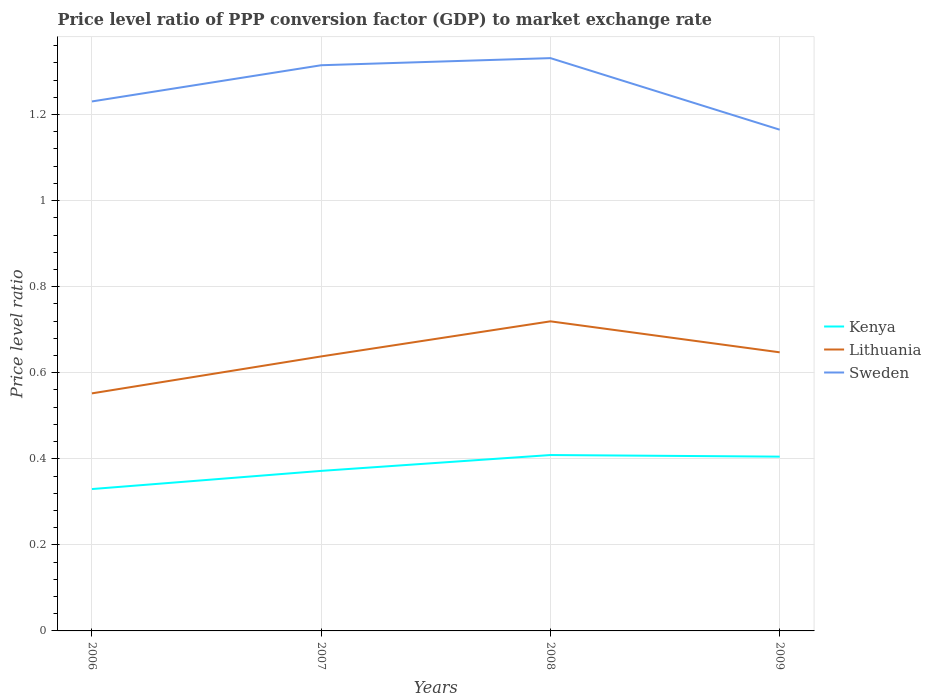How many different coloured lines are there?
Offer a very short reply. 3. Is the number of lines equal to the number of legend labels?
Make the answer very short. Yes. Across all years, what is the maximum price level ratio in Kenya?
Provide a succinct answer. 0.33. What is the total price level ratio in Sweden in the graph?
Your response must be concise. 0.07. What is the difference between the highest and the second highest price level ratio in Kenya?
Your answer should be compact. 0.08. What is the difference between the highest and the lowest price level ratio in Lithuania?
Make the answer very short. 2. Is the price level ratio in Kenya strictly greater than the price level ratio in Lithuania over the years?
Ensure brevity in your answer.  Yes. How many lines are there?
Provide a succinct answer. 3. How many years are there in the graph?
Your response must be concise. 4. What is the difference between two consecutive major ticks on the Y-axis?
Keep it short and to the point. 0.2. Does the graph contain any zero values?
Provide a succinct answer. No. Does the graph contain grids?
Your answer should be compact. Yes. Where does the legend appear in the graph?
Provide a succinct answer. Center right. How are the legend labels stacked?
Your answer should be compact. Vertical. What is the title of the graph?
Offer a very short reply. Price level ratio of PPP conversion factor (GDP) to market exchange rate. What is the label or title of the X-axis?
Your answer should be compact. Years. What is the label or title of the Y-axis?
Your response must be concise. Price level ratio. What is the Price level ratio in Kenya in 2006?
Give a very brief answer. 0.33. What is the Price level ratio of Lithuania in 2006?
Ensure brevity in your answer.  0.55. What is the Price level ratio of Sweden in 2006?
Offer a terse response. 1.23. What is the Price level ratio in Kenya in 2007?
Give a very brief answer. 0.37. What is the Price level ratio of Lithuania in 2007?
Ensure brevity in your answer.  0.64. What is the Price level ratio of Sweden in 2007?
Your response must be concise. 1.31. What is the Price level ratio of Kenya in 2008?
Your answer should be compact. 0.41. What is the Price level ratio of Lithuania in 2008?
Provide a short and direct response. 0.72. What is the Price level ratio in Sweden in 2008?
Offer a terse response. 1.33. What is the Price level ratio in Kenya in 2009?
Provide a succinct answer. 0.4. What is the Price level ratio of Lithuania in 2009?
Your answer should be compact. 0.65. What is the Price level ratio in Sweden in 2009?
Your answer should be very brief. 1.16. Across all years, what is the maximum Price level ratio of Kenya?
Your response must be concise. 0.41. Across all years, what is the maximum Price level ratio of Lithuania?
Your answer should be very brief. 0.72. Across all years, what is the maximum Price level ratio in Sweden?
Your answer should be very brief. 1.33. Across all years, what is the minimum Price level ratio in Kenya?
Keep it short and to the point. 0.33. Across all years, what is the minimum Price level ratio of Lithuania?
Your response must be concise. 0.55. Across all years, what is the minimum Price level ratio in Sweden?
Your answer should be compact. 1.16. What is the total Price level ratio in Kenya in the graph?
Your response must be concise. 1.52. What is the total Price level ratio in Lithuania in the graph?
Provide a succinct answer. 2.56. What is the total Price level ratio of Sweden in the graph?
Keep it short and to the point. 5.04. What is the difference between the Price level ratio of Kenya in 2006 and that in 2007?
Your answer should be compact. -0.04. What is the difference between the Price level ratio in Lithuania in 2006 and that in 2007?
Give a very brief answer. -0.09. What is the difference between the Price level ratio in Sweden in 2006 and that in 2007?
Make the answer very short. -0.08. What is the difference between the Price level ratio in Kenya in 2006 and that in 2008?
Your response must be concise. -0.08. What is the difference between the Price level ratio in Lithuania in 2006 and that in 2008?
Your response must be concise. -0.17. What is the difference between the Price level ratio in Sweden in 2006 and that in 2008?
Your answer should be compact. -0.1. What is the difference between the Price level ratio in Kenya in 2006 and that in 2009?
Your answer should be very brief. -0.08. What is the difference between the Price level ratio in Lithuania in 2006 and that in 2009?
Your answer should be very brief. -0.1. What is the difference between the Price level ratio of Sweden in 2006 and that in 2009?
Provide a succinct answer. 0.07. What is the difference between the Price level ratio of Kenya in 2007 and that in 2008?
Keep it short and to the point. -0.04. What is the difference between the Price level ratio of Lithuania in 2007 and that in 2008?
Offer a terse response. -0.08. What is the difference between the Price level ratio in Sweden in 2007 and that in 2008?
Offer a very short reply. -0.02. What is the difference between the Price level ratio of Kenya in 2007 and that in 2009?
Your answer should be compact. -0.03. What is the difference between the Price level ratio in Lithuania in 2007 and that in 2009?
Make the answer very short. -0.01. What is the difference between the Price level ratio of Sweden in 2007 and that in 2009?
Offer a very short reply. 0.15. What is the difference between the Price level ratio in Kenya in 2008 and that in 2009?
Offer a very short reply. 0. What is the difference between the Price level ratio of Lithuania in 2008 and that in 2009?
Your answer should be compact. 0.07. What is the difference between the Price level ratio of Sweden in 2008 and that in 2009?
Make the answer very short. 0.17. What is the difference between the Price level ratio of Kenya in 2006 and the Price level ratio of Lithuania in 2007?
Your response must be concise. -0.31. What is the difference between the Price level ratio of Kenya in 2006 and the Price level ratio of Sweden in 2007?
Give a very brief answer. -0.98. What is the difference between the Price level ratio of Lithuania in 2006 and the Price level ratio of Sweden in 2007?
Offer a very short reply. -0.76. What is the difference between the Price level ratio in Kenya in 2006 and the Price level ratio in Lithuania in 2008?
Your answer should be very brief. -0.39. What is the difference between the Price level ratio of Kenya in 2006 and the Price level ratio of Sweden in 2008?
Provide a short and direct response. -1. What is the difference between the Price level ratio of Lithuania in 2006 and the Price level ratio of Sweden in 2008?
Give a very brief answer. -0.78. What is the difference between the Price level ratio in Kenya in 2006 and the Price level ratio in Lithuania in 2009?
Make the answer very short. -0.32. What is the difference between the Price level ratio of Kenya in 2006 and the Price level ratio of Sweden in 2009?
Keep it short and to the point. -0.84. What is the difference between the Price level ratio in Lithuania in 2006 and the Price level ratio in Sweden in 2009?
Ensure brevity in your answer.  -0.61. What is the difference between the Price level ratio of Kenya in 2007 and the Price level ratio of Lithuania in 2008?
Provide a short and direct response. -0.35. What is the difference between the Price level ratio of Kenya in 2007 and the Price level ratio of Sweden in 2008?
Make the answer very short. -0.96. What is the difference between the Price level ratio in Lithuania in 2007 and the Price level ratio in Sweden in 2008?
Provide a short and direct response. -0.69. What is the difference between the Price level ratio in Kenya in 2007 and the Price level ratio in Lithuania in 2009?
Offer a terse response. -0.28. What is the difference between the Price level ratio of Kenya in 2007 and the Price level ratio of Sweden in 2009?
Your response must be concise. -0.79. What is the difference between the Price level ratio of Lithuania in 2007 and the Price level ratio of Sweden in 2009?
Your answer should be very brief. -0.53. What is the difference between the Price level ratio of Kenya in 2008 and the Price level ratio of Lithuania in 2009?
Keep it short and to the point. -0.24. What is the difference between the Price level ratio of Kenya in 2008 and the Price level ratio of Sweden in 2009?
Your response must be concise. -0.76. What is the difference between the Price level ratio in Lithuania in 2008 and the Price level ratio in Sweden in 2009?
Provide a short and direct response. -0.45. What is the average Price level ratio in Kenya per year?
Make the answer very short. 0.38. What is the average Price level ratio of Lithuania per year?
Provide a succinct answer. 0.64. What is the average Price level ratio of Sweden per year?
Make the answer very short. 1.26. In the year 2006, what is the difference between the Price level ratio in Kenya and Price level ratio in Lithuania?
Provide a short and direct response. -0.22. In the year 2006, what is the difference between the Price level ratio in Kenya and Price level ratio in Sweden?
Offer a terse response. -0.9. In the year 2006, what is the difference between the Price level ratio in Lithuania and Price level ratio in Sweden?
Offer a terse response. -0.68. In the year 2007, what is the difference between the Price level ratio in Kenya and Price level ratio in Lithuania?
Ensure brevity in your answer.  -0.27. In the year 2007, what is the difference between the Price level ratio of Kenya and Price level ratio of Sweden?
Provide a short and direct response. -0.94. In the year 2007, what is the difference between the Price level ratio in Lithuania and Price level ratio in Sweden?
Offer a terse response. -0.68. In the year 2008, what is the difference between the Price level ratio of Kenya and Price level ratio of Lithuania?
Ensure brevity in your answer.  -0.31. In the year 2008, what is the difference between the Price level ratio of Kenya and Price level ratio of Sweden?
Give a very brief answer. -0.92. In the year 2008, what is the difference between the Price level ratio of Lithuania and Price level ratio of Sweden?
Give a very brief answer. -0.61. In the year 2009, what is the difference between the Price level ratio of Kenya and Price level ratio of Lithuania?
Give a very brief answer. -0.24. In the year 2009, what is the difference between the Price level ratio in Kenya and Price level ratio in Sweden?
Offer a terse response. -0.76. In the year 2009, what is the difference between the Price level ratio of Lithuania and Price level ratio of Sweden?
Offer a terse response. -0.52. What is the ratio of the Price level ratio of Kenya in 2006 to that in 2007?
Provide a short and direct response. 0.89. What is the ratio of the Price level ratio of Lithuania in 2006 to that in 2007?
Provide a short and direct response. 0.87. What is the ratio of the Price level ratio in Sweden in 2006 to that in 2007?
Give a very brief answer. 0.94. What is the ratio of the Price level ratio of Kenya in 2006 to that in 2008?
Your response must be concise. 0.81. What is the ratio of the Price level ratio of Lithuania in 2006 to that in 2008?
Provide a short and direct response. 0.77. What is the ratio of the Price level ratio in Sweden in 2006 to that in 2008?
Your answer should be compact. 0.92. What is the ratio of the Price level ratio in Kenya in 2006 to that in 2009?
Offer a terse response. 0.81. What is the ratio of the Price level ratio in Lithuania in 2006 to that in 2009?
Offer a terse response. 0.85. What is the ratio of the Price level ratio in Sweden in 2006 to that in 2009?
Provide a succinct answer. 1.06. What is the ratio of the Price level ratio in Kenya in 2007 to that in 2008?
Your response must be concise. 0.91. What is the ratio of the Price level ratio of Lithuania in 2007 to that in 2008?
Provide a succinct answer. 0.89. What is the ratio of the Price level ratio in Sweden in 2007 to that in 2008?
Provide a succinct answer. 0.99. What is the ratio of the Price level ratio of Kenya in 2007 to that in 2009?
Your answer should be compact. 0.92. What is the ratio of the Price level ratio in Sweden in 2007 to that in 2009?
Your answer should be compact. 1.13. What is the ratio of the Price level ratio in Kenya in 2008 to that in 2009?
Ensure brevity in your answer.  1.01. What is the ratio of the Price level ratio in Lithuania in 2008 to that in 2009?
Keep it short and to the point. 1.11. What is the ratio of the Price level ratio of Sweden in 2008 to that in 2009?
Your answer should be very brief. 1.14. What is the difference between the highest and the second highest Price level ratio of Kenya?
Provide a succinct answer. 0. What is the difference between the highest and the second highest Price level ratio of Lithuania?
Your answer should be compact. 0.07. What is the difference between the highest and the second highest Price level ratio in Sweden?
Your answer should be compact. 0.02. What is the difference between the highest and the lowest Price level ratio of Kenya?
Keep it short and to the point. 0.08. What is the difference between the highest and the lowest Price level ratio in Lithuania?
Offer a terse response. 0.17. What is the difference between the highest and the lowest Price level ratio of Sweden?
Your answer should be very brief. 0.17. 